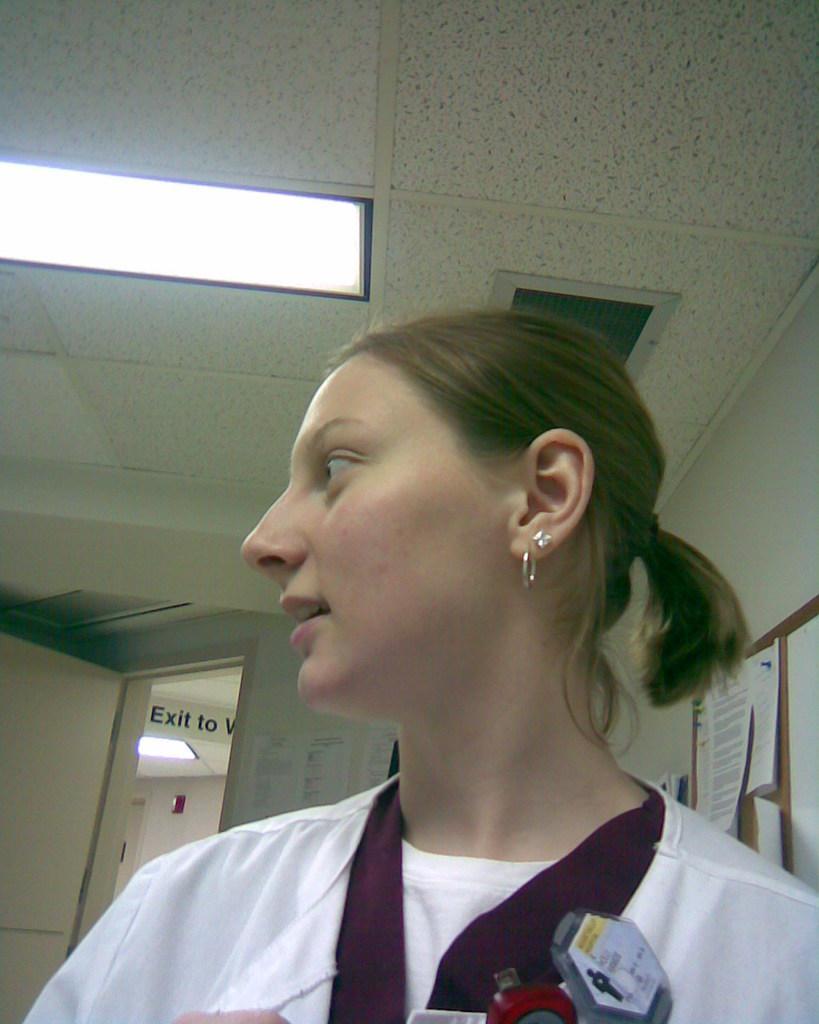How would you summarize this image in a sentence or two? In this picture we can see a girl wearing white color top looking on the left side. Behind we can see a notice board with many papers stick on it. 